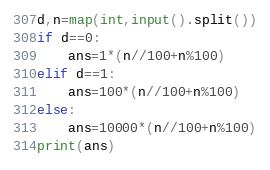<code> <loc_0><loc_0><loc_500><loc_500><_Python_>d,n=map(int,input().split())
if d==0:
    ans=1*(n//100+n%100)
elif d==1:
    ans=100*(n//100+n%100)
else:
    ans=10000*(n//100+n%100)
print(ans)</code> 